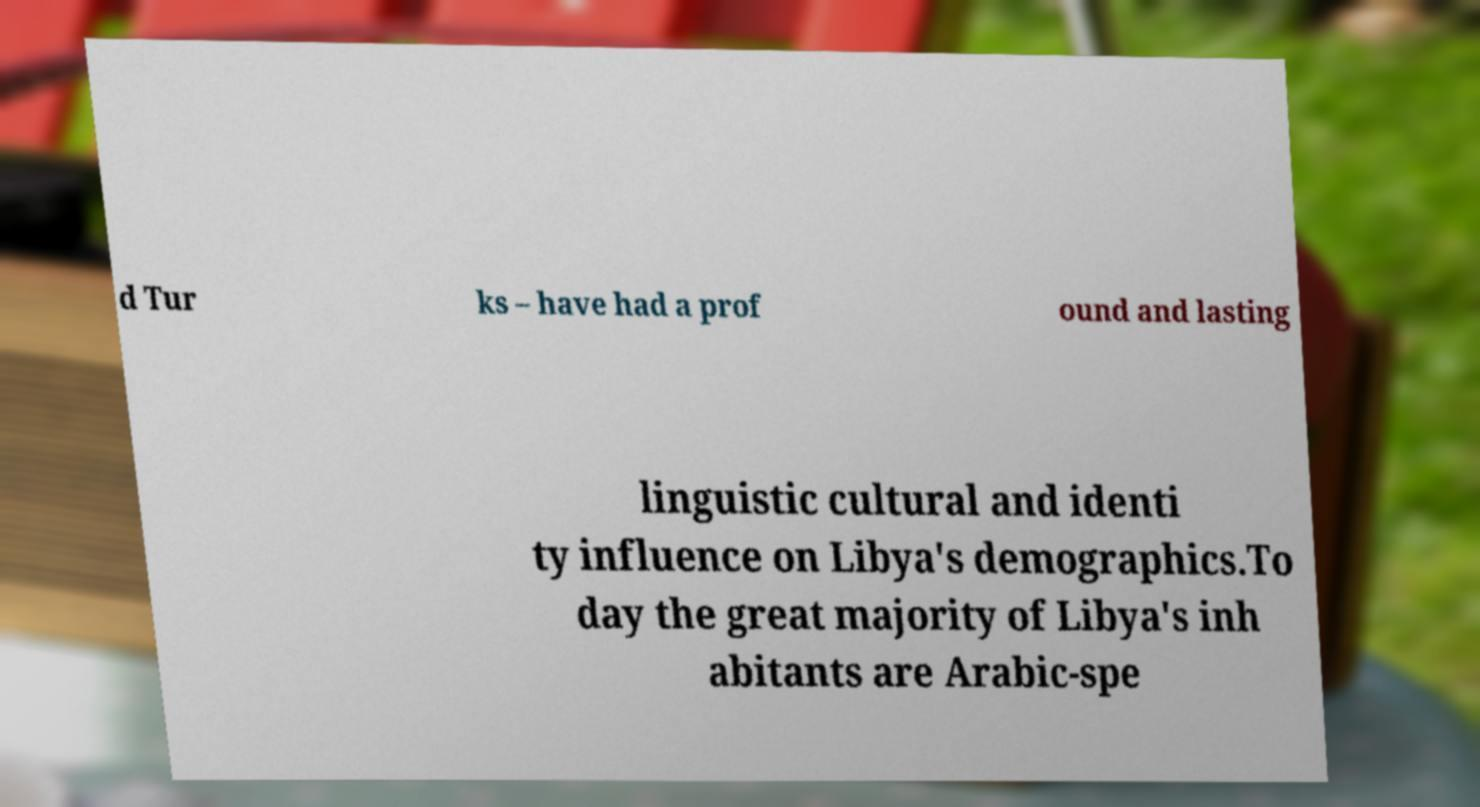What messages or text are displayed in this image? I need them in a readable, typed format. d Tur ks – have had a prof ound and lasting linguistic cultural and identi ty influence on Libya's demographics.To day the great majority of Libya's inh abitants are Arabic-spe 